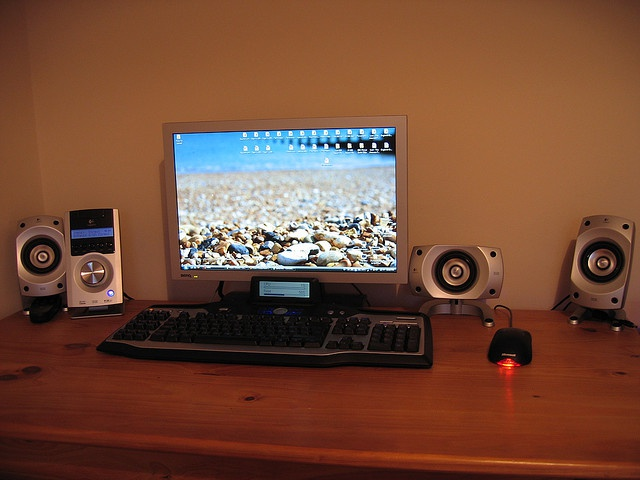Describe the objects in this image and their specific colors. I can see tv in maroon, lightgray, lightblue, brown, and black tones, keyboard in maroon, black, and brown tones, and mouse in maroon, black, red, and brown tones in this image. 